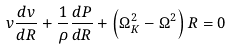Convert formula to latex. <formula><loc_0><loc_0><loc_500><loc_500>v { \frac { d v } { d R } } + \frac { 1 } { \rho } \frac { d P } { d R } + \left ( \Omega _ { K } ^ { 2 } - \Omega ^ { 2 } \right ) R = 0</formula> 